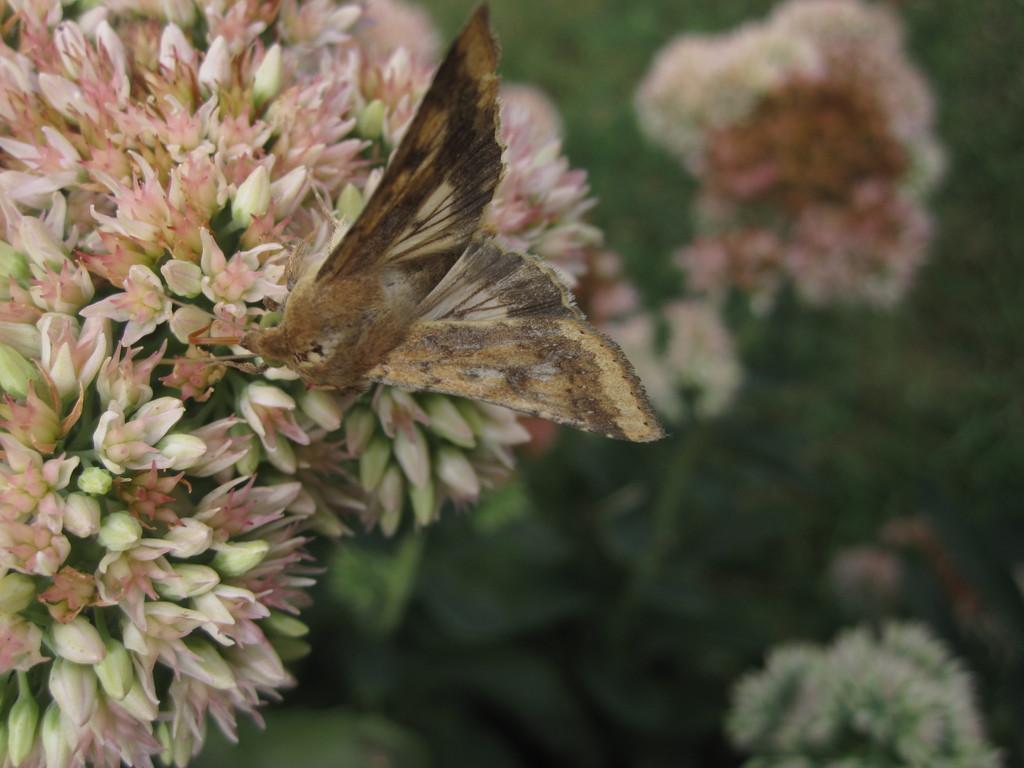Please provide a concise description of this image. In this image I can see flowers and a butterfly visible on flowers on the left side. 